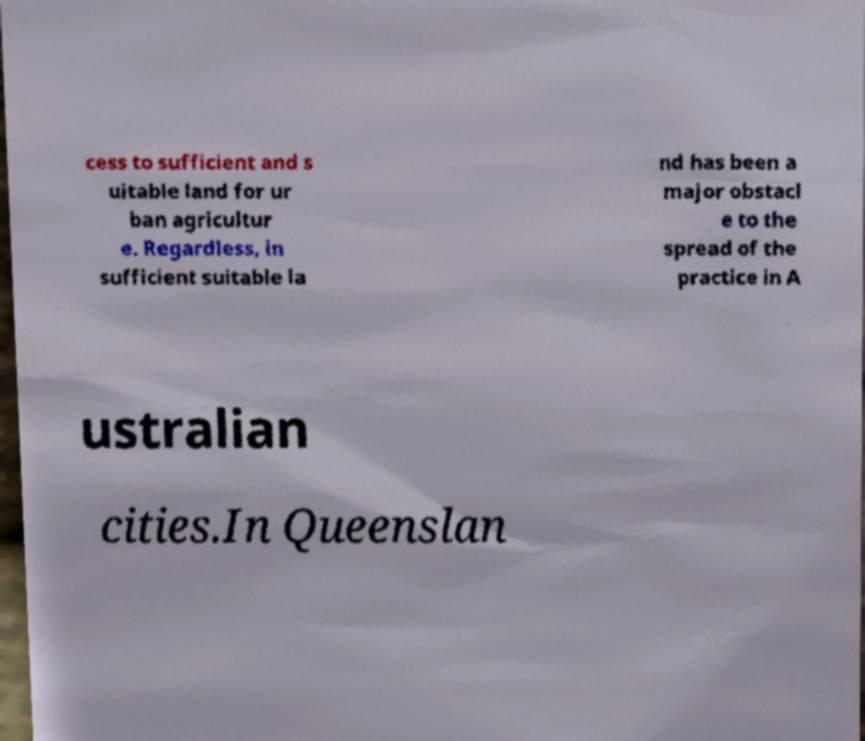Can you read and provide the text displayed in the image?This photo seems to have some interesting text. Can you extract and type it out for me? cess to sufficient and s uitable land for ur ban agricultur e. Regardless, in sufficient suitable la nd has been a major obstacl e to the spread of the practice in A ustralian cities.In Queenslan 